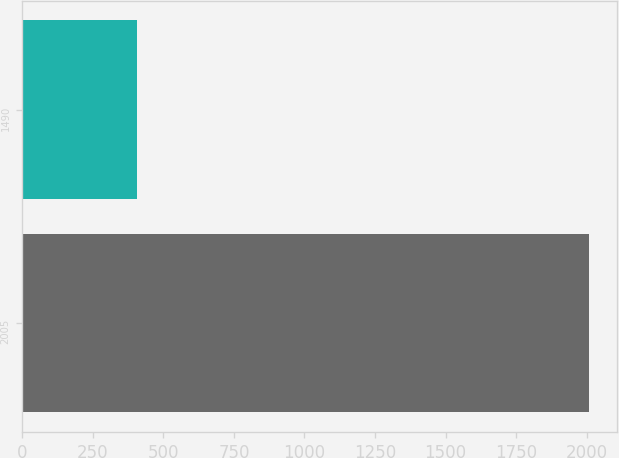<chart> <loc_0><loc_0><loc_500><loc_500><bar_chart><fcel>2005<fcel>1490<nl><fcel>2009<fcel>406<nl></chart> 